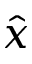Convert formula to latex. <formula><loc_0><loc_0><loc_500><loc_500>\hat { x }</formula> 